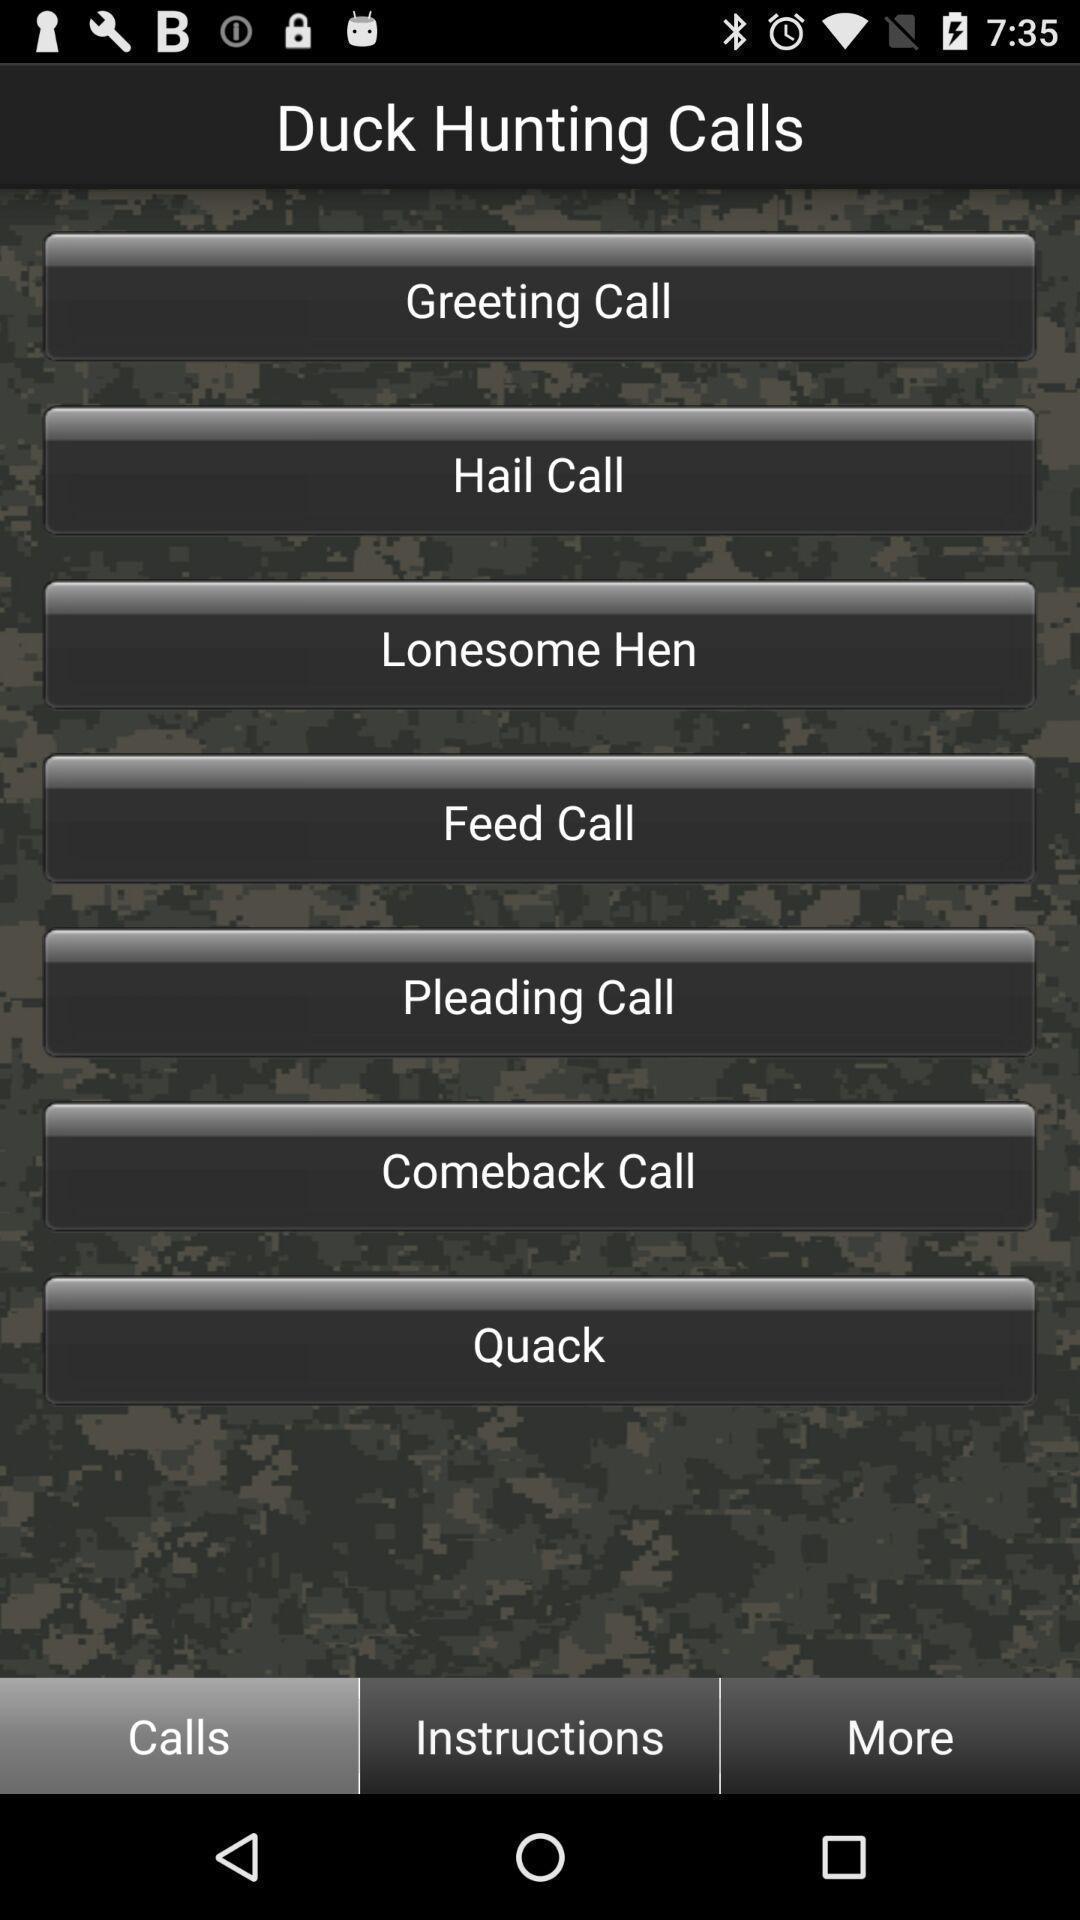Describe the content in this image. Page displaying various options in a calls app. 